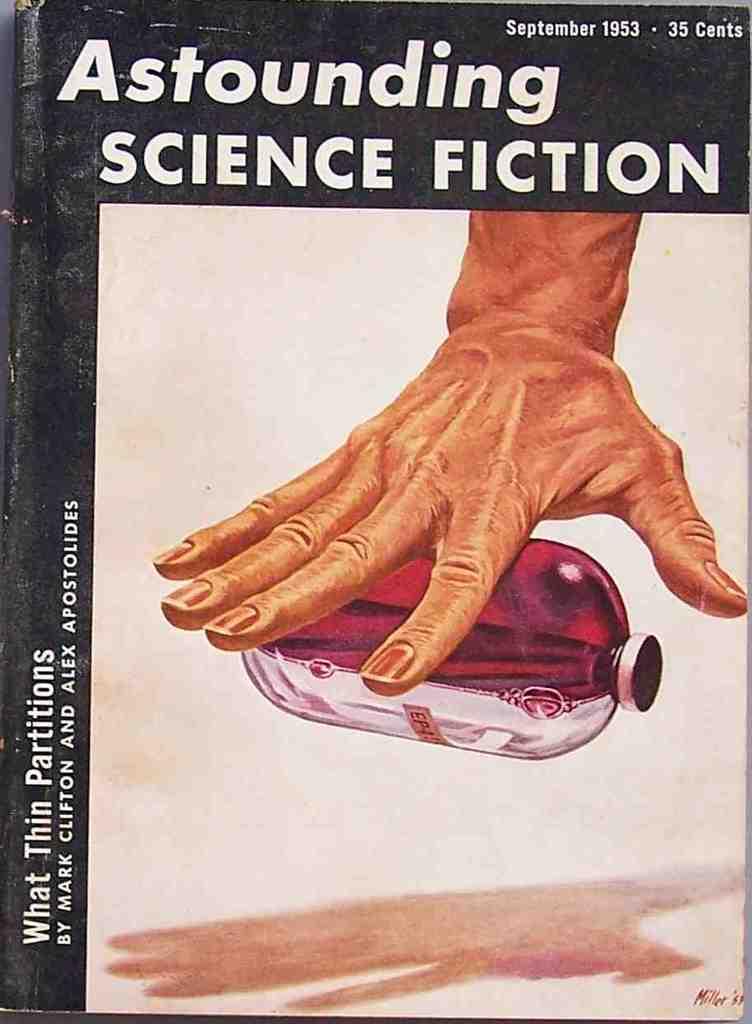What is the name  of the book?
Offer a terse response. Astounding science fiction. What month and year was the book issued?
Offer a very short reply. September 1953. 